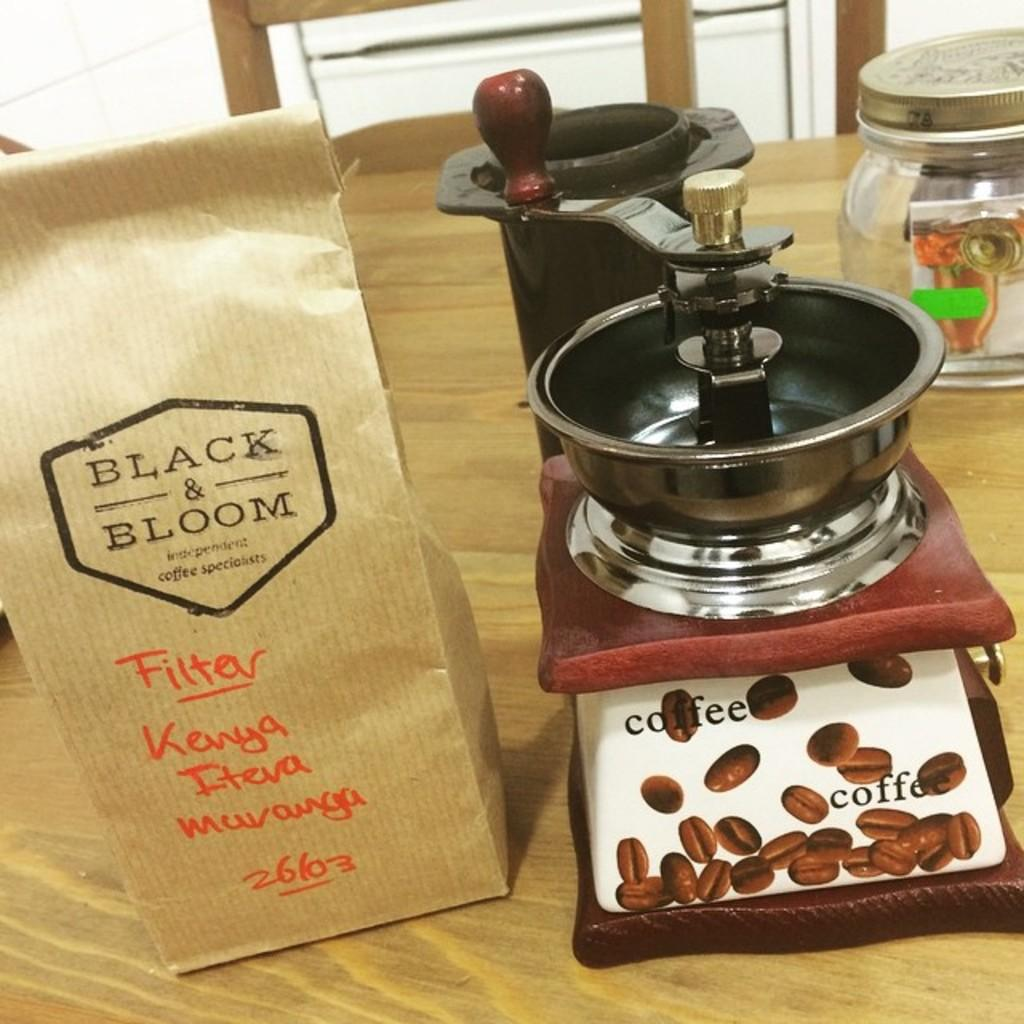<image>
Render a clear and concise summary of the photo. A coffee grinder is next to black & bloom coffee. 